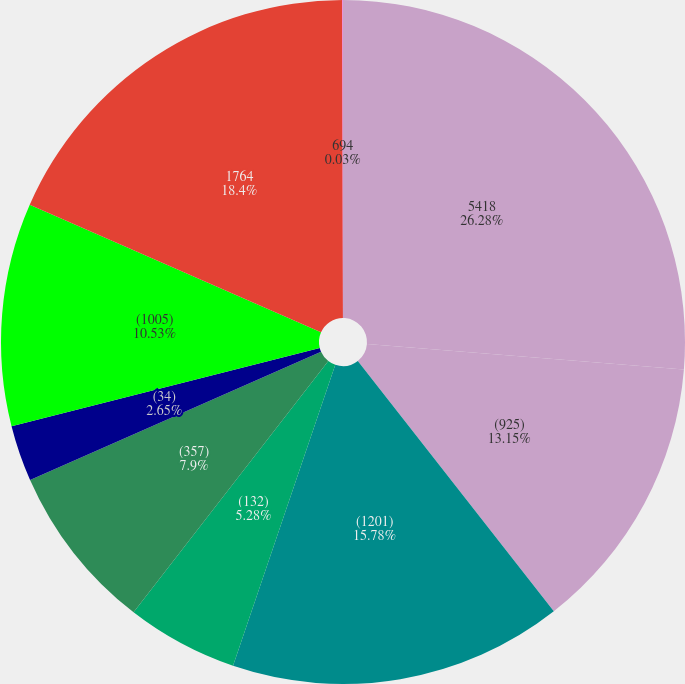<chart> <loc_0><loc_0><loc_500><loc_500><pie_chart><fcel>5418<fcel>(925)<fcel>(1201)<fcel>(132)<fcel>(357)<fcel>(34)<fcel>(1005)<fcel>1764<fcel>694<nl><fcel>26.28%<fcel>13.15%<fcel>15.78%<fcel>5.28%<fcel>7.9%<fcel>2.65%<fcel>10.53%<fcel>18.4%<fcel>0.03%<nl></chart> 